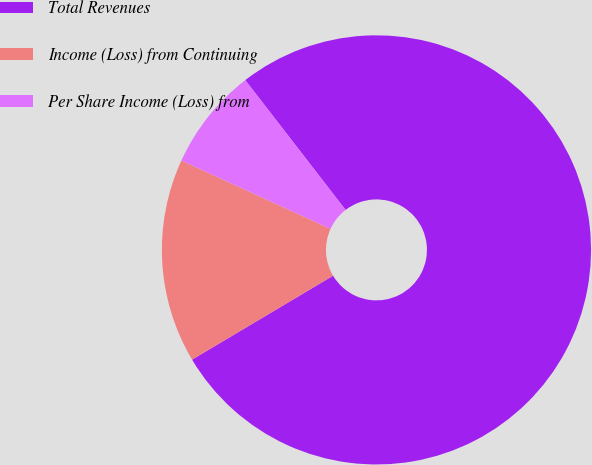Convert chart. <chart><loc_0><loc_0><loc_500><loc_500><pie_chart><fcel>Total Revenues<fcel>Income (Loss) from Continuing<fcel>Per Share Income (Loss) from<nl><fcel>76.92%<fcel>15.38%<fcel>7.69%<nl></chart> 